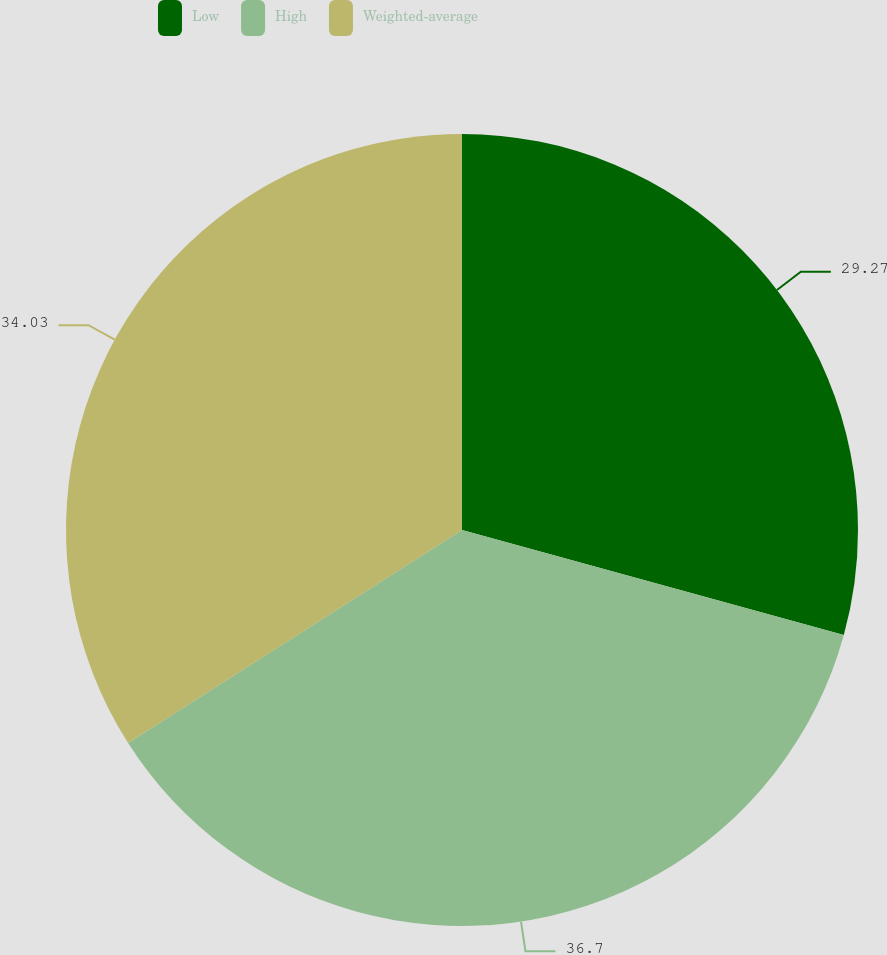<chart> <loc_0><loc_0><loc_500><loc_500><pie_chart><fcel>Low<fcel>High<fcel>Weighted-average<nl><fcel>29.27%<fcel>36.69%<fcel>34.03%<nl></chart> 